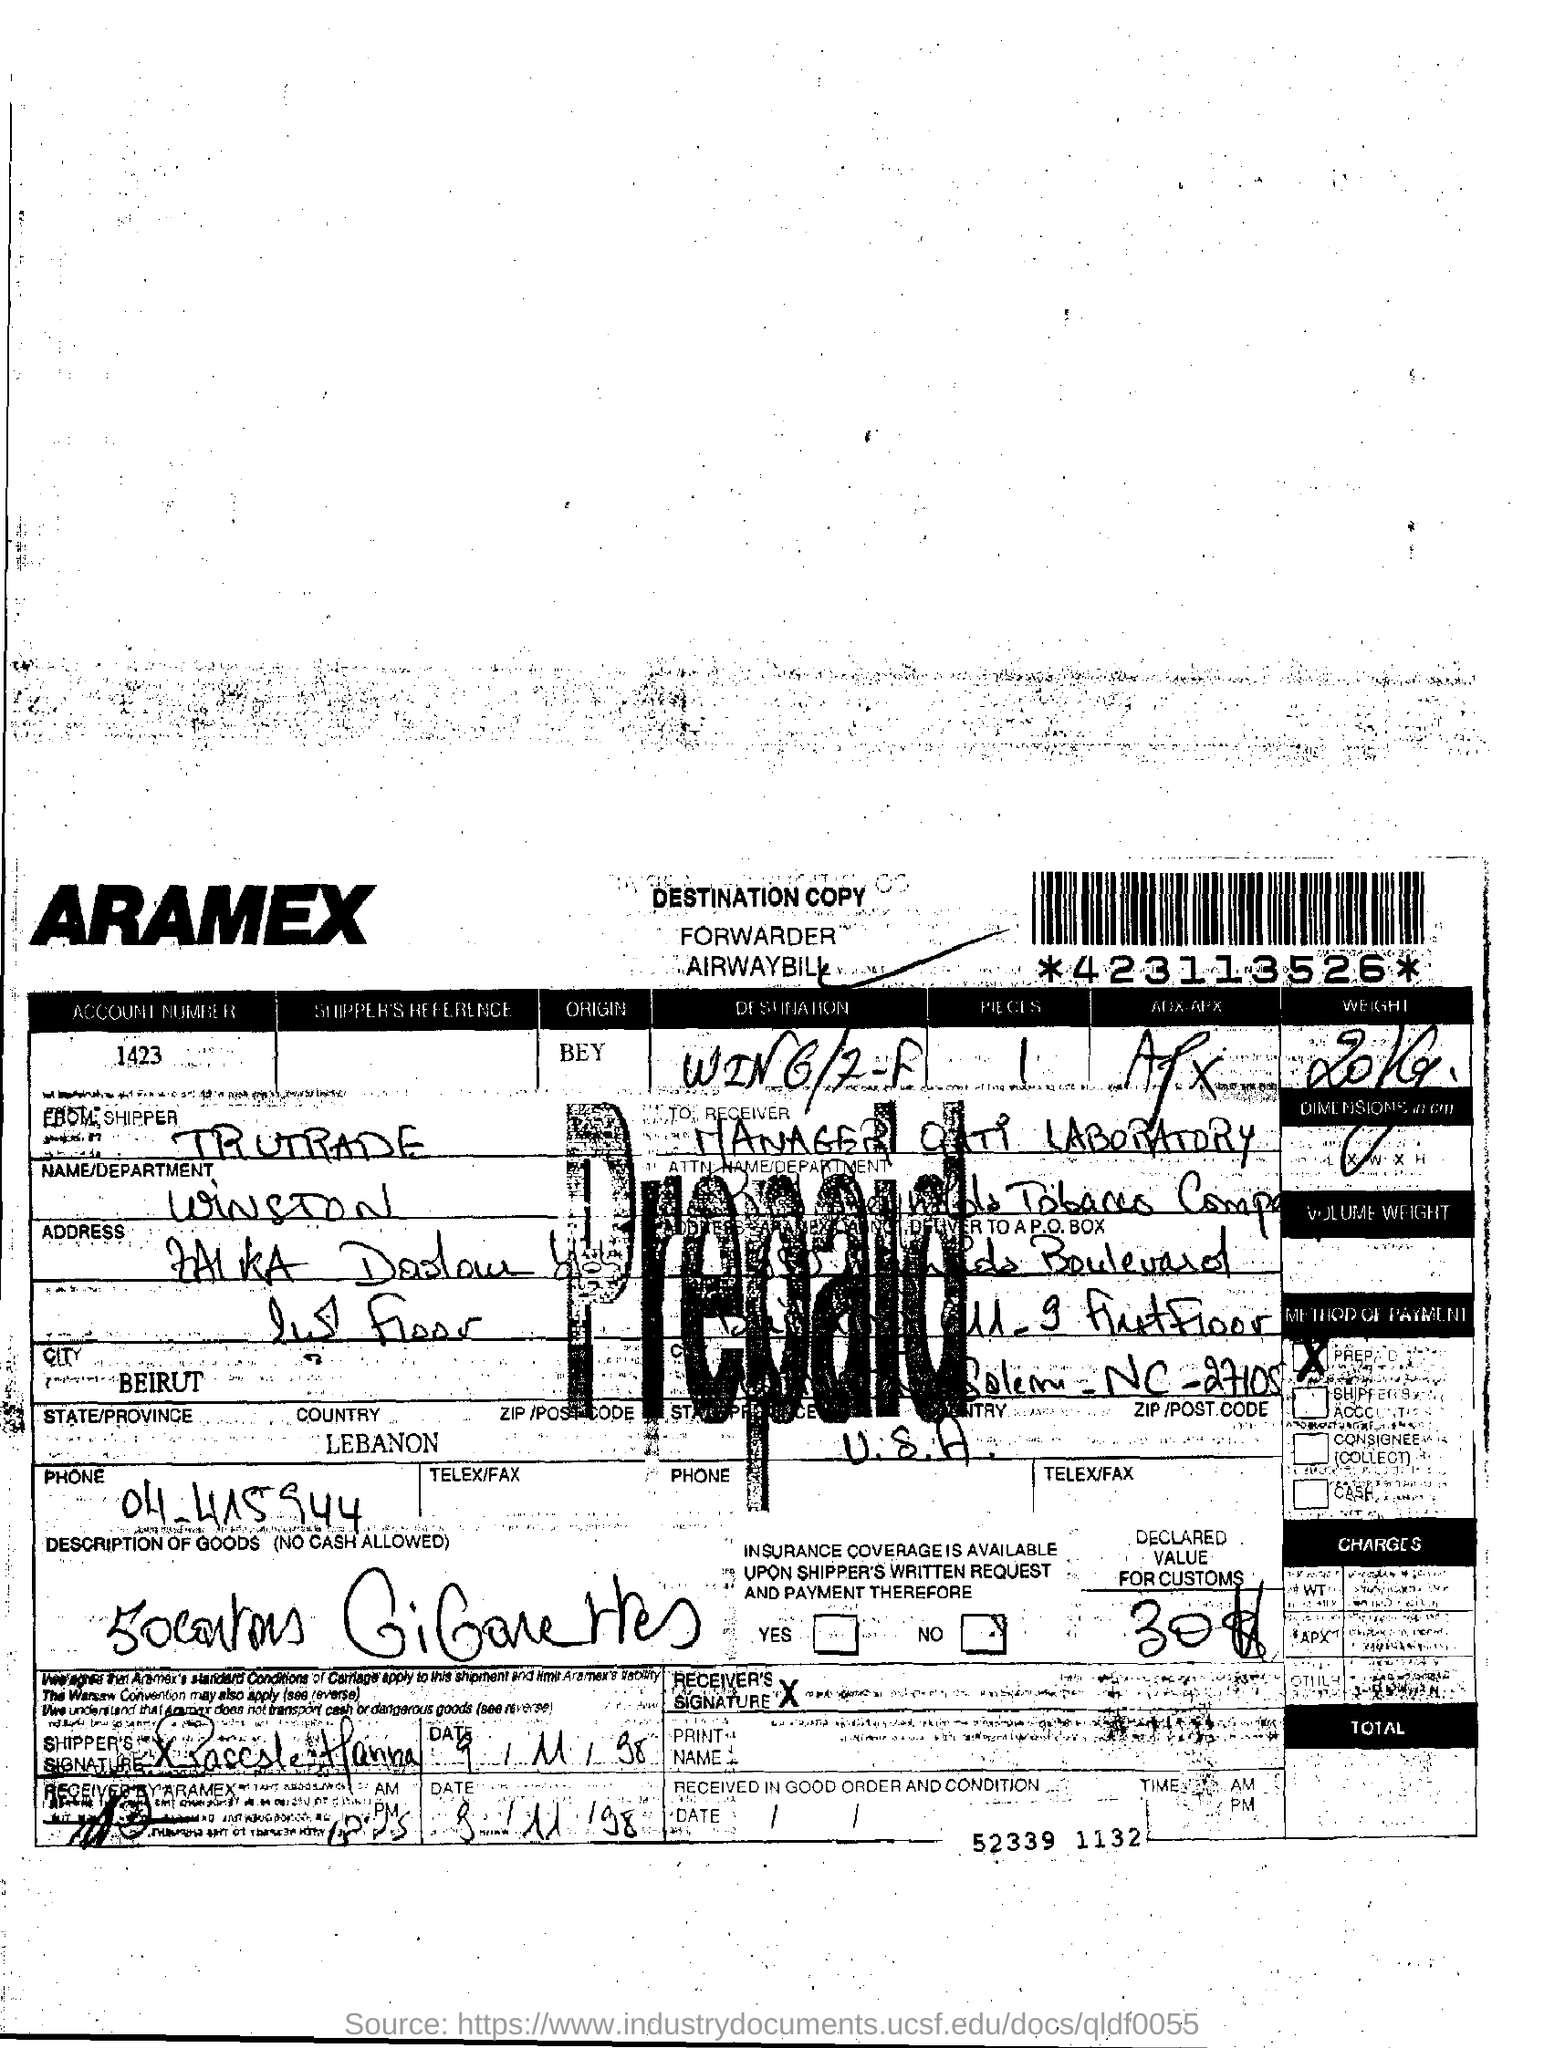What is the origin ?
Keep it short and to the point. BEY. What is the name of the city ?
Your answer should be compact. BEIRUT. What is the name of the country ?
Your response must be concise. LEBANON. What is the name/department
Ensure brevity in your answer.  WINSTON. 